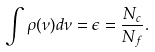<formula> <loc_0><loc_0><loc_500><loc_500>\int \rho ( \nu ) d \nu = \epsilon = \frac { N _ { c } } { N _ { f } } .</formula> 